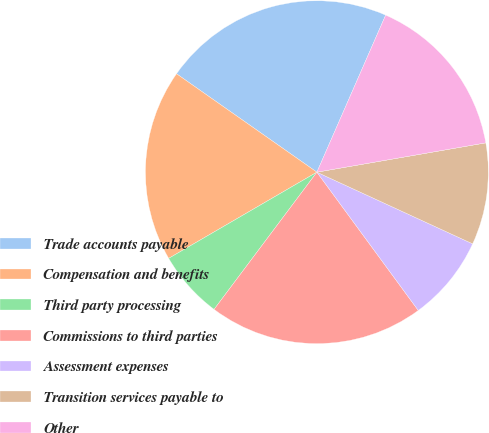Convert chart to OTSL. <chart><loc_0><loc_0><loc_500><loc_500><pie_chart><fcel>Trade accounts payable<fcel>Compensation and benefits<fcel>Third party processing<fcel>Commissions to third parties<fcel>Assessment expenses<fcel>Transition services payable to<fcel>Other<nl><fcel>21.84%<fcel>18.12%<fcel>6.38%<fcel>20.31%<fcel>8.07%<fcel>9.6%<fcel>15.7%<nl></chart> 